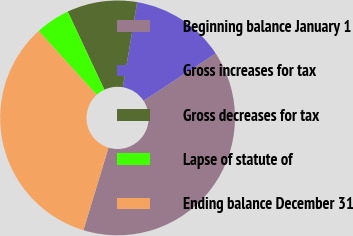Convert chart to OTSL. <chart><loc_0><loc_0><loc_500><loc_500><pie_chart><fcel>Beginning balance January 1<fcel>Gross increases for tax<fcel>Gross decreases for tax<fcel>Lapse of statute of<fcel>Ending balance December 31<nl><fcel>38.96%<fcel>13.07%<fcel>9.65%<fcel>4.76%<fcel>33.56%<nl></chart> 